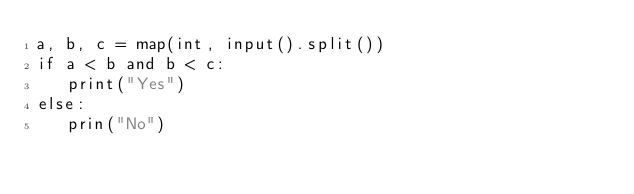<code> <loc_0><loc_0><loc_500><loc_500><_Python_>a, b, c = map(int, input().split())
if a < b and b < c:
   print("Yes")
else:
   prin("No")

</code> 